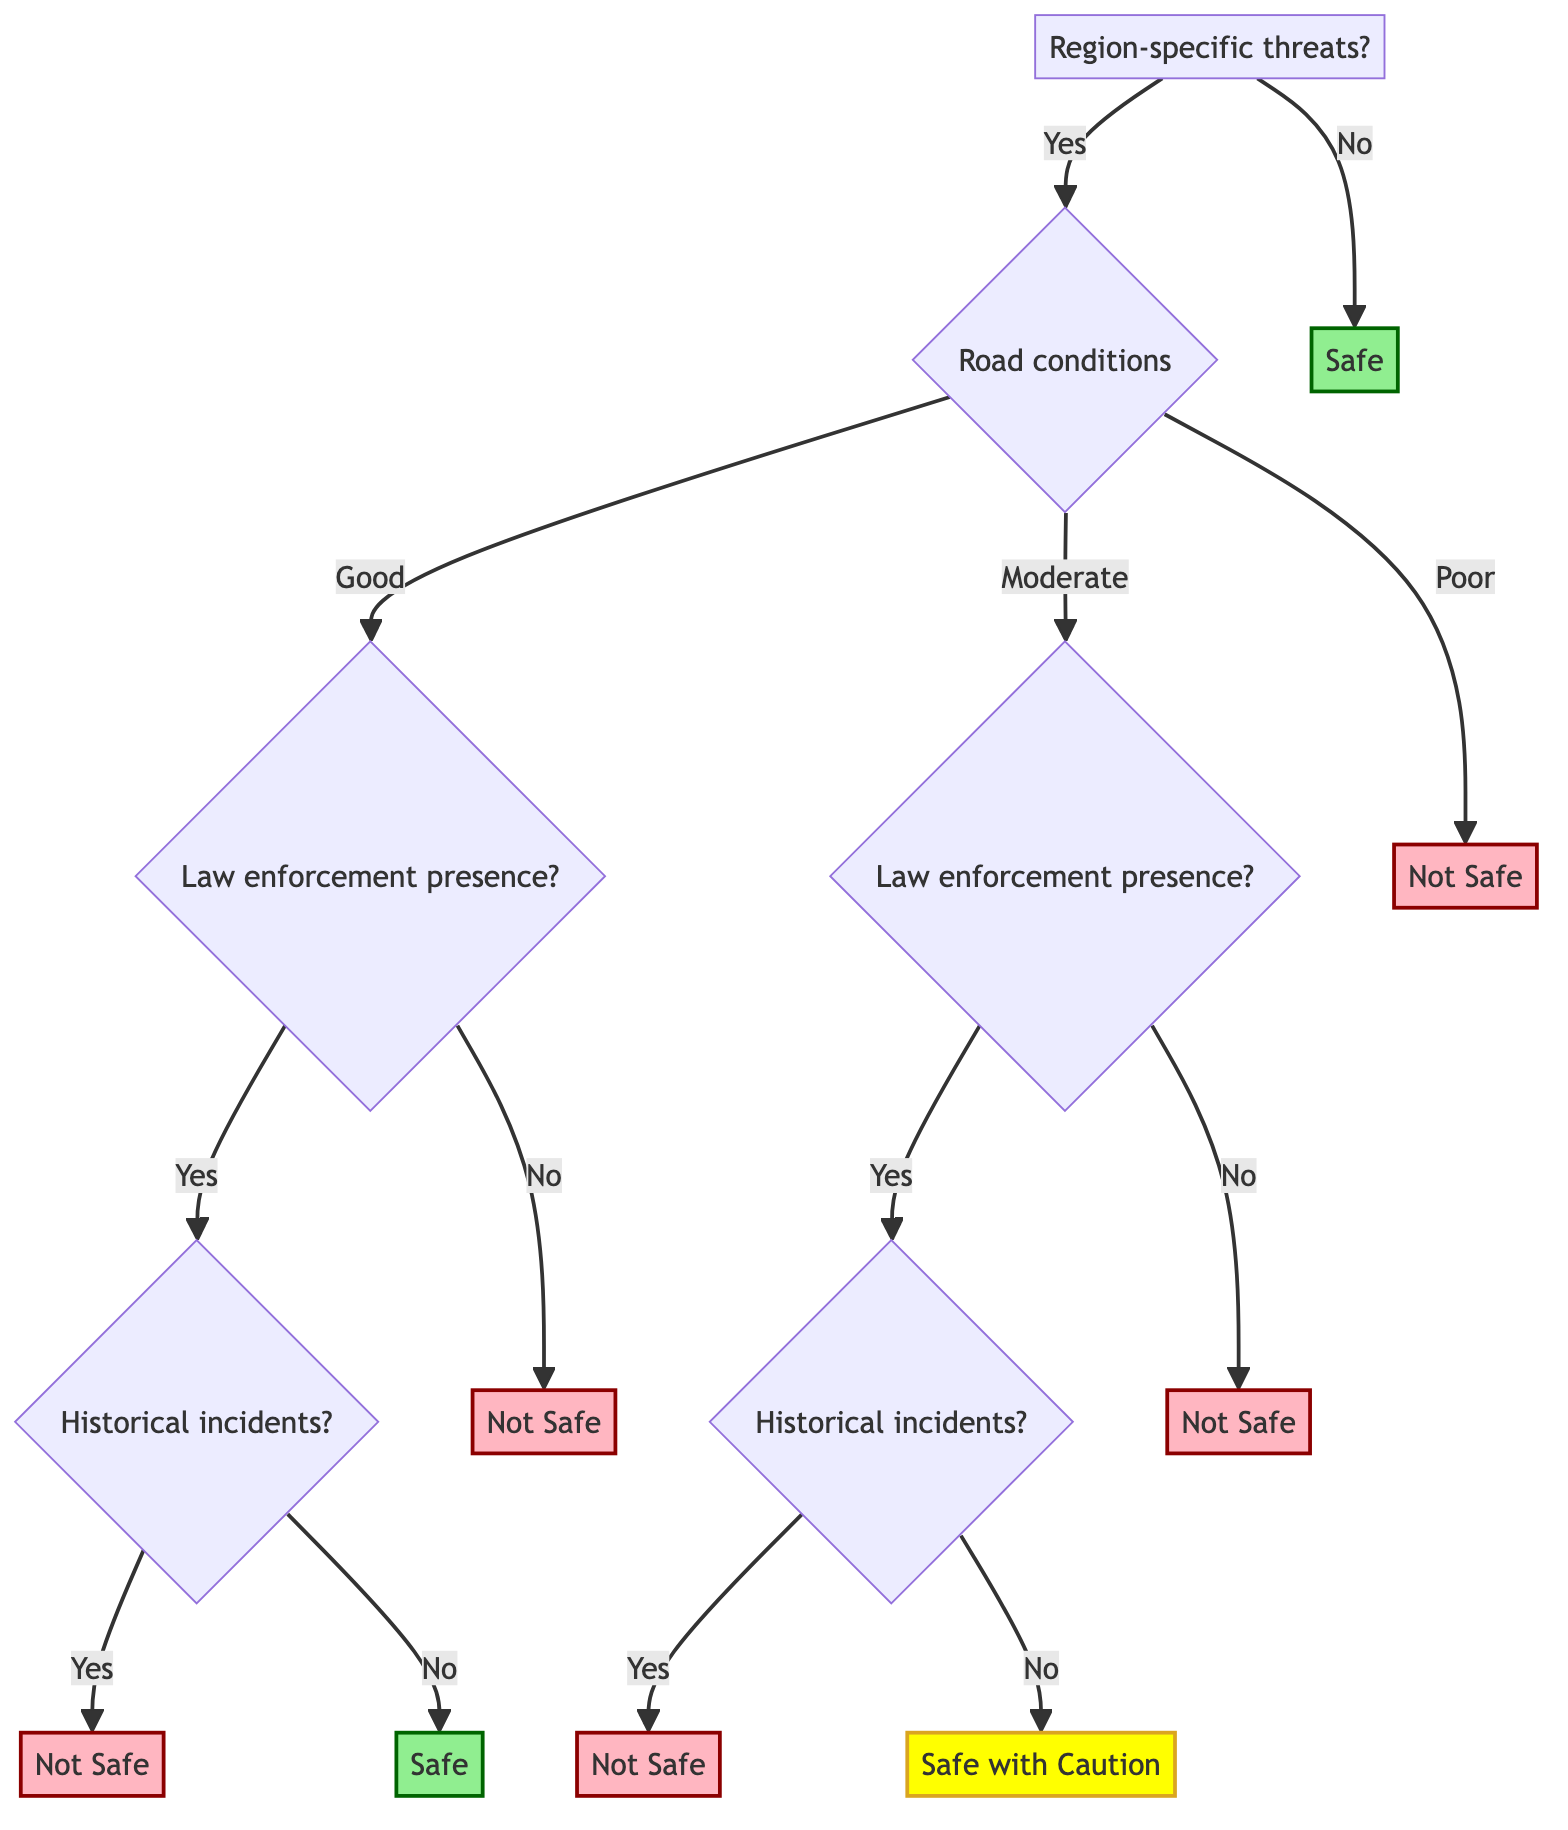What is the root node of the decision tree? The root node is "region-specific threats." It is the initial decision point in the diagram that determines the subsequent path based on the presence of threats in the region.
Answer: region-specific threats How many attributes are there under road conditions? There are three attributes under road conditions: "Good," "Moderate," and "Poor." This shows the various states of road conditions that can influence safety.
Answer: 3 What happens if the road conditions are Poor? If the road conditions are Poor, the decision leads directly to "Not Safe," indicating that the route is unsafe regardless of other factors.
Answer: Not Safe If there is high crime and Good road conditions, what is the next question asked? If there is a high crime situation and Good road conditions, the next question is about "law enforcement presence," specifically whether there is a visible police presence, military checkpoints, or private security services.
Answer: law enforcement presence What is the outcome if the road conditions are Moderate and there is no law enforcement presence? In this scenario, if road conditions are Moderate and there is no law enforcement presence, the outcome is "Not Safe," indicating a high level of risk for traveling.
Answer: Not Safe What is the final outcome if the road conditions are Good, there is no law enforcement presence, and there are historical incidents? In this situation, the outcome is "Not Safe," since the presence of historical incidents combined with no law enforcement presence presents a significant risk.
Answer: Not Safe What is indicated by the node labeled "Safe with Caution"? The node labeled "Safe with Caution" indicates that the route may be manageable but requires extra vigilance due to moderate threats or potential issues like historical incidents despite some law enforcement presence.
Answer: Safe with Caution What is the significance of the diagram being a Decision Tree? A Decision Tree allows for a structured evaluation of multiple criteria and outcomes based on the binary (yes/no) decisions at each node, making it easy to visualize the paths leading to different safety assessments.
Answer: Structured evaluation 